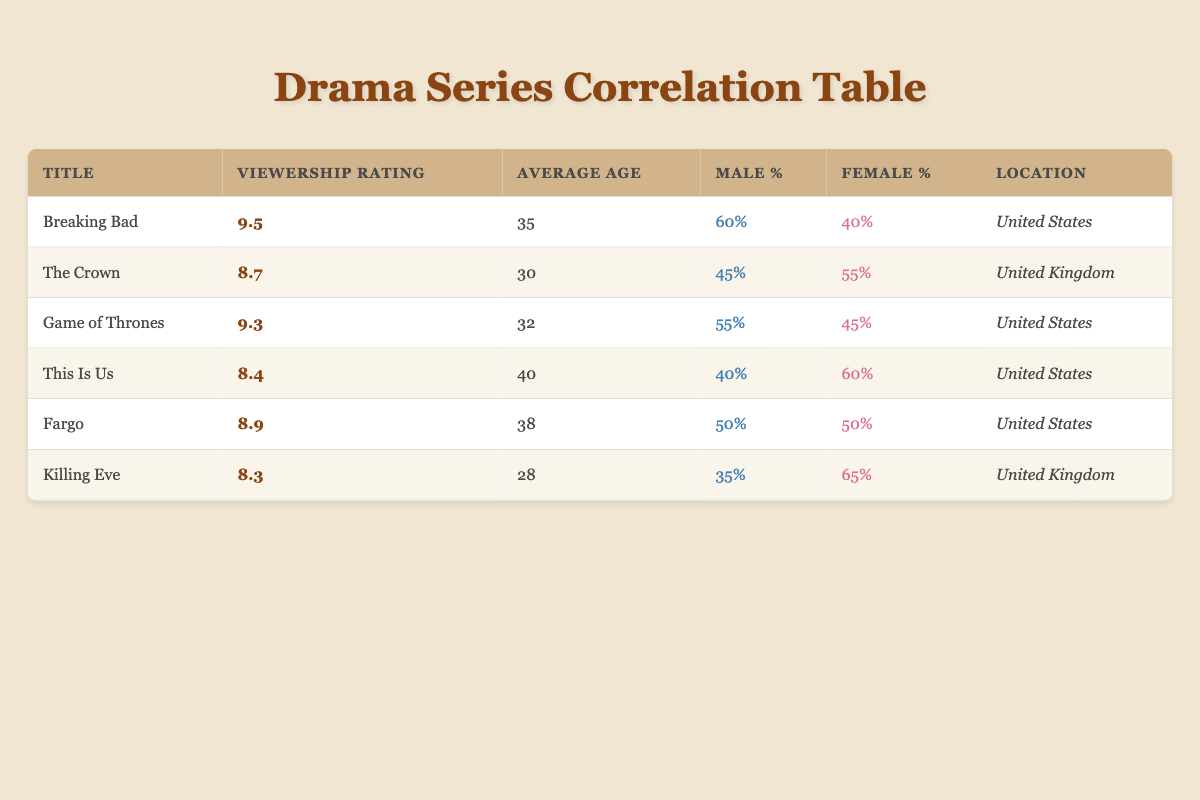What is the viewership rating of "This Is Us"? According to the table, the row for "This Is Us" shows a viewership rating of 8.4. This value can be directly retrieved from the corresponding column under the title "This Is Us".
Answer: 8.4 What percentage of the audience for "Killing Eve" is female? Looking at the row for "Killing Eve", the column labeled "Female %" shows a value of 65%. This is directly stated in the table, so it can be quickly referenced.
Answer: 65% Which drama series has the highest average age of viewers? The average age for each series can be compared: "Breaking Bad" has 35, "The Crown" has 30, "Game of Thrones" has 32, "This Is Us" has 40, "Fargo" has 38, and "Killing Eve" has 28. The highest number here is 40 for "This Is Us".
Answer: This Is Us What are the average percentages of male and female viewers across all series listed? To find the averages, we sum the male percentages (60 + 45 + 55 + 40 + 50 + 35) = 285 and divide by 6 (the number of series), resulting in an average male percentage of 47.5%. Similarly, the female percentages sum to (40 + 55 + 45 + 60 + 50 + 65) = 315, giving an average female percentage of 52.5%.
Answer: Male: 47.5%, Female: 52.5% Is the viewership rating of "Fargo" higher than that of "Killing Eve"? The viewership rating for "Fargo" is 8.9 and for "Killing Eve" it is 8.3. Since 8.9 is greater than 8.3, this indicates that "Fargo" does indeed have a higher rating.
Answer: Yes Which series has the lowest viewership rating and what is that rating? By checking all the viewership ratings, I see that "Killing Eve" has the lowest rating at 8.3. This can be determined by comparing all the values in the "Viewership Rating" column.
Answer: Killing Eve, 8.3 Which series has more male viewers, "Breaking Bad" or "Game of Thrones"? "Breaking Bad" has 60% male viewers while "Game of Thrones" has 55%. Since 60% is higher than 55%, "Breaking Bad" has more male viewers than "Game of Thrones".
Answer: Breaking Bad Is the average viewership rating of drama series in the United States greater than 8.5? The viewership ratings for the US-based shows are 9.5 (Breaking Bad), 9.3 (Game of Thrones), 8.4 (This Is Us), and 8.9 (Fargo). The average of these ratings is (9.5 + 9.3 + 8.4 + 8.9) / 4 = 9.03, which is greater than 8.5.
Answer: Yes What is the gender ratio of the audience for "The Crown"? "The Crown" has a percentage of 45% male viewers and 55% female viewers. The ratio can be represented as 45:55, which can also be simplified to 9:11 when dividing both percentages by 5.
Answer: 9:11 